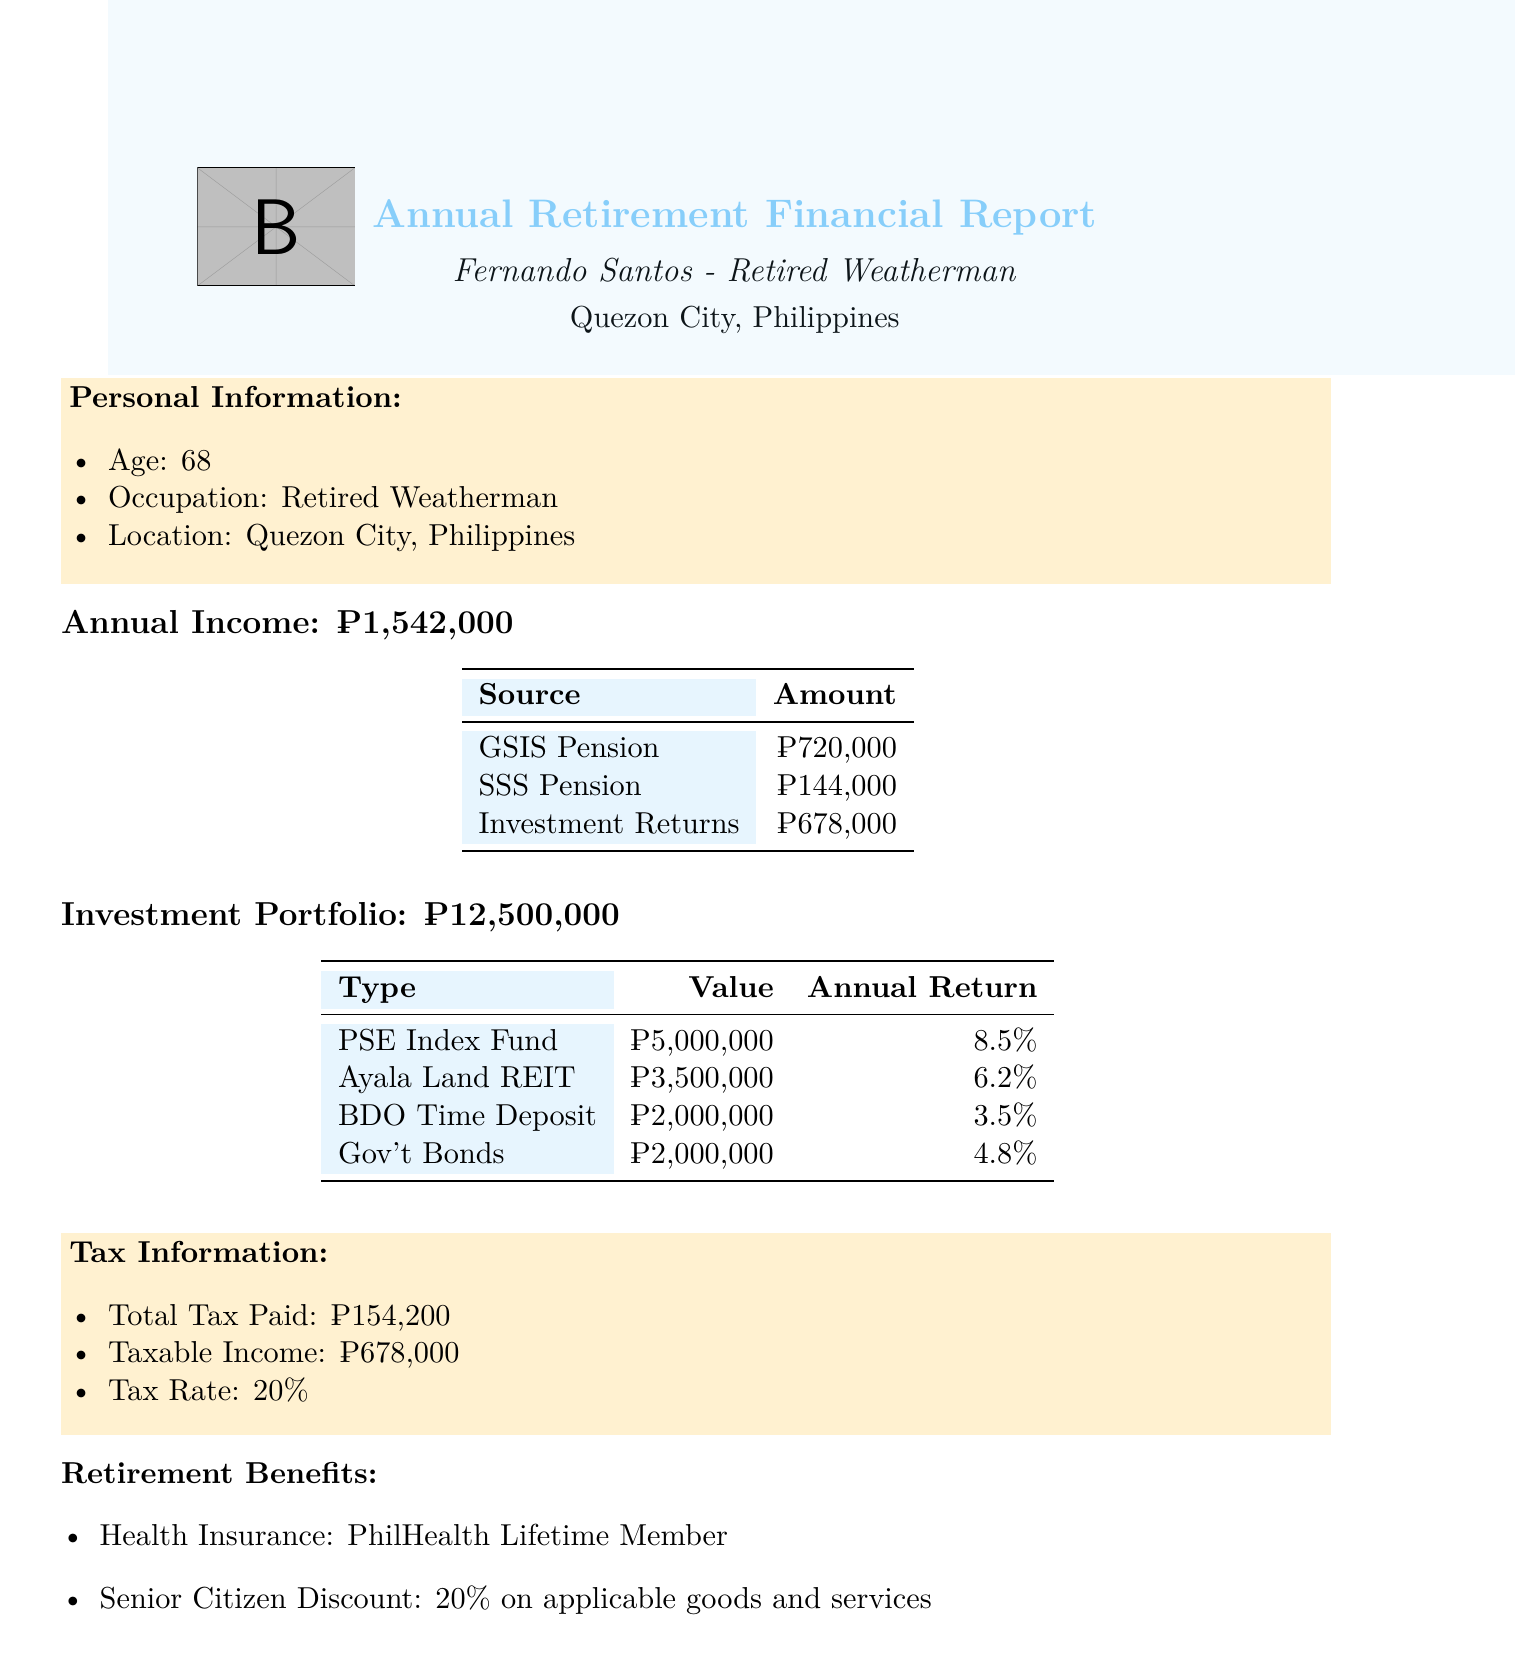What is the total annual income? The total annual income is displayed in the document and is calculated from all income sources combined.
Answer: ₱1,542,000 How much does Fernando receive from GSIS Pension? The GSIS Pension amount is directly stated in the income breakdown section of the document.
Answer: ₱720,000 What is the total investment portfolio value? The total value of the investment portfolio is provided in the document as one specific amount.
Answer: ₱12,500,000 What is the annual return of the Philippine Stock Exchange Index Fund? The annual return for this specific investment type is listed within the investment portfolio section.
Answer: 8.5% How much tax did Fernando pay? The total tax paid figure can be found in the tax information section of the document.
Answer: ₱154,200 What is the taxable income? The document specifies the taxable income clearly in the tax information section.
Answer: ₱678,000 Which health insurance provider is mentioned? The health insurance provider for retirement benefits is stated directly in the document.
Answer: PhilHealth Lifetime Member What discount does Fernando receive as a senior citizen? The senior citizen discount percentage is listed under the retirement benefits section in the document.
Answer: 20% What is the annual return percentage of BDO Unibank Time Deposit? The annual return percentage for this specific investment is detailed in the investment portfolio.
Answer: 3.5% 